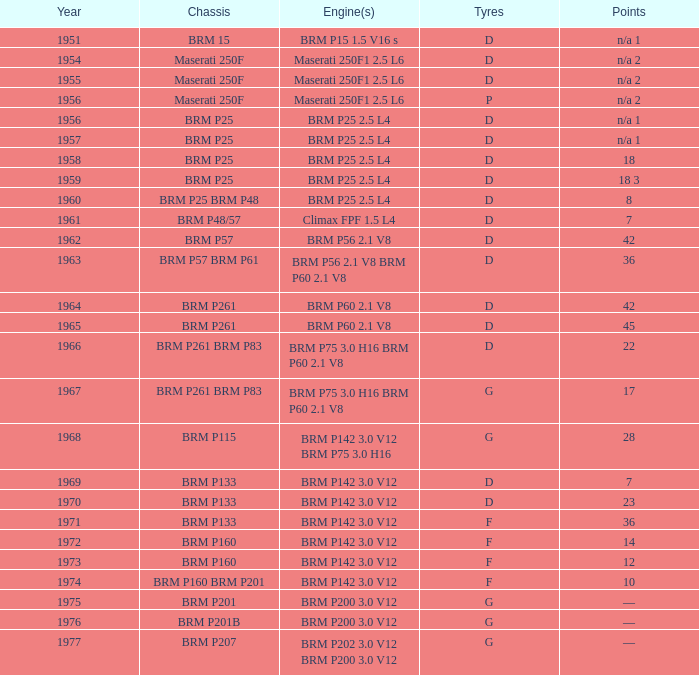Name the sum of year for engine of brm p202 3.0 v12 brm p200 3.0 v12 1977.0. 